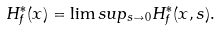<formula> <loc_0><loc_0><loc_500><loc_500>H _ { f } ^ { * } ( x ) = \lim s u p _ { s \to 0 } H _ { f } ^ { * } ( x , s ) .</formula> 